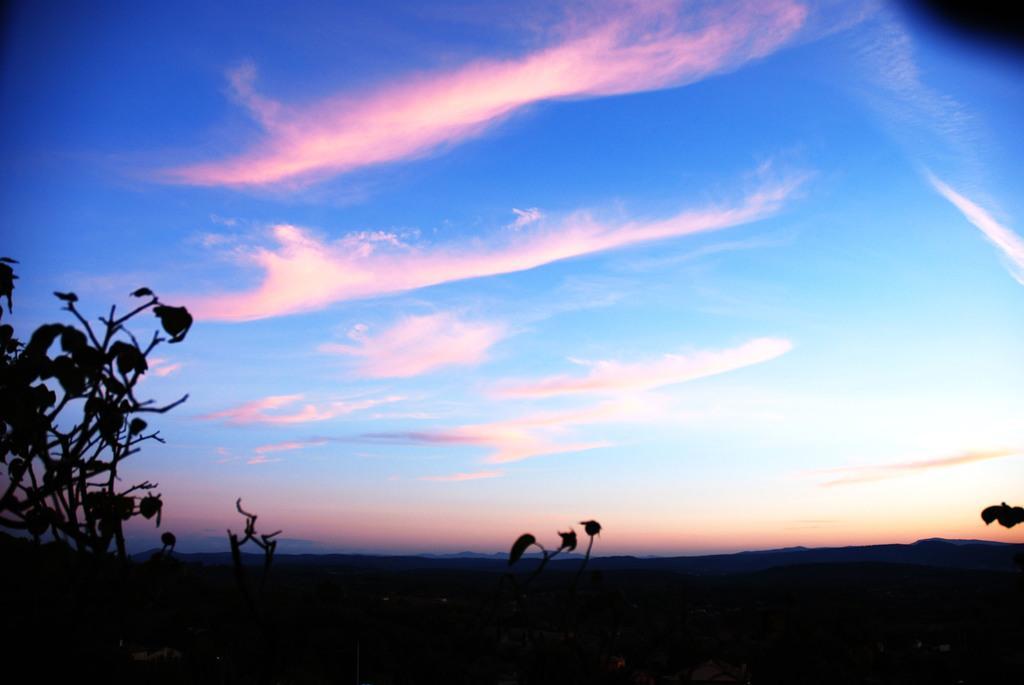In one or two sentences, can you explain what this image depicts? In this picture, we can see plants, ground, and the sky with clouds. 